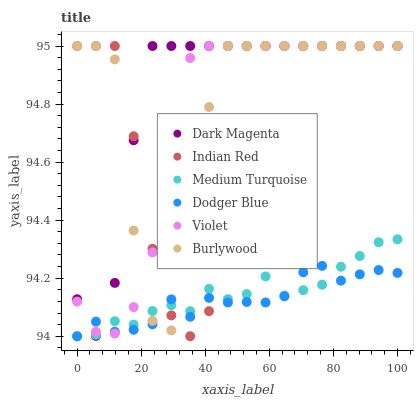Does Dodger Blue have the minimum area under the curve?
Answer yes or no. Yes. Does Dark Magenta have the maximum area under the curve?
Answer yes or no. Yes. Does Burlywood have the minimum area under the curve?
Answer yes or no. No. Does Burlywood have the maximum area under the curve?
Answer yes or no. No. Is Medium Turquoise the smoothest?
Answer yes or no. Yes. Is Burlywood the roughest?
Answer yes or no. Yes. Is Dodger Blue the smoothest?
Answer yes or no. No. Is Dodger Blue the roughest?
Answer yes or no. No. Does Dodger Blue have the lowest value?
Answer yes or no. Yes. Does Burlywood have the lowest value?
Answer yes or no. No. Does Indian Red have the highest value?
Answer yes or no. Yes. Does Dodger Blue have the highest value?
Answer yes or no. No. Does Dark Magenta intersect Medium Turquoise?
Answer yes or no. Yes. Is Dark Magenta less than Medium Turquoise?
Answer yes or no. No. Is Dark Magenta greater than Medium Turquoise?
Answer yes or no. No. 